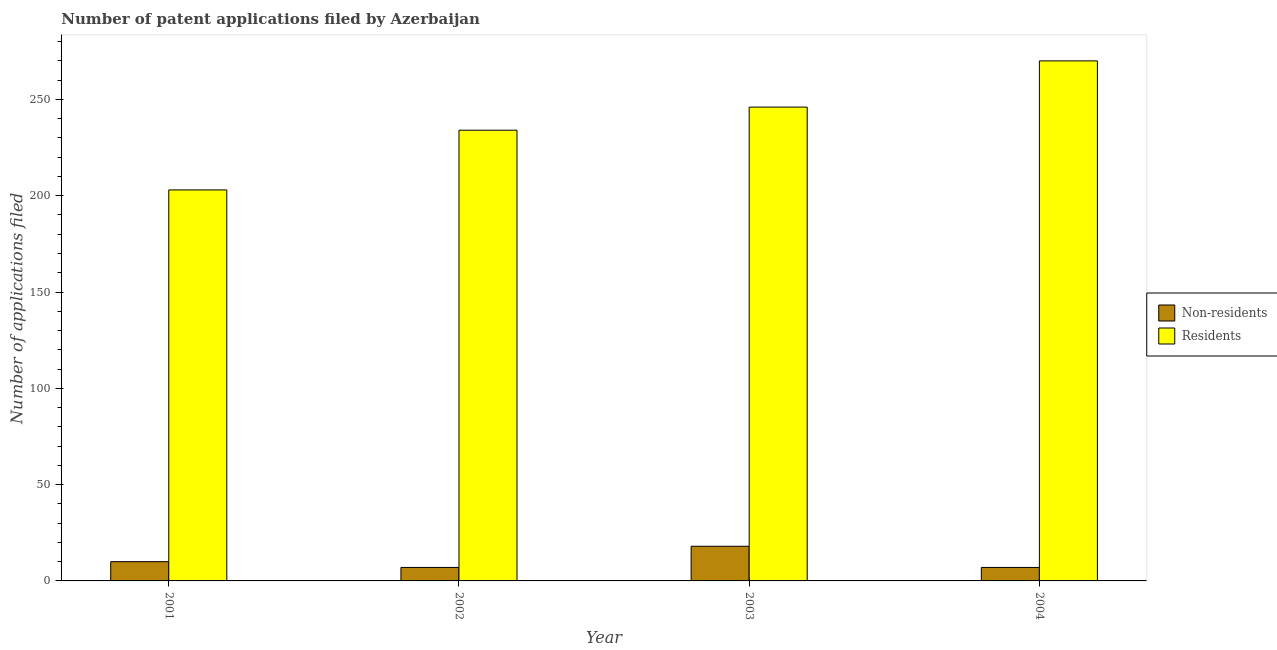Are the number of bars per tick equal to the number of legend labels?
Your answer should be compact. Yes. Are the number of bars on each tick of the X-axis equal?
Your response must be concise. Yes. How many bars are there on the 1st tick from the right?
Ensure brevity in your answer.  2. What is the number of patent applications by non residents in 2001?
Offer a very short reply. 10. Across all years, what is the maximum number of patent applications by non residents?
Your answer should be compact. 18. Across all years, what is the minimum number of patent applications by non residents?
Give a very brief answer. 7. In which year was the number of patent applications by non residents maximum?
Provide a short and direct response. 2003. In which year was the number of patent applications by residents minimum?
Give a very brief answer. 2001. What is the total number of patent applications by non residents in the graph?
Offer a very short reply. 42. What is the difference between the number of patent applications by non residents in 2001 and that in 2002?
Offer a terse response. 3. What is the difference between the number of patent applications by non residents in 2003 and the number of patent applications by residents in 2002?
Offer a very short reply. 11. In the year 2002, what is the difference between the number of patent applications by residents and number of patent applications by non residents?
Make the answer very short. 0. What is the ratio of the number of patent applications by residents in 2002 to that in 2003?
Your response must be concise. 0.95. Is the difference between the number of patent applications by residents in 2001 and 2003 greater than the difference between the number of patent applications by non residents in 2001 and 2003?
Give a very brief answer. No. What is the difference between the highest and the second highest number of patent applications by non residents?
Your answer should be very brief. 8. What is the difference between the highest and the lowest number of patent applications by non residents?
Give a very brief answer. 11. Is the sum of the number of patent applications by residents in 2002 and 2003 greater than the maximum number of patent applications by non residents across all years?
Keep it short and to the point. Yes. What does the 2nd bar from the left in 2003 represents?
Your answer should be compact. Residents. What does the 2nd bar from the right in 2003 represents?
Make the answer very short. Non-residents. How many bars are there?
Your answer should be compact. 8. Are all the bars in the graph horizontal?
Your answer should be compact. No. What is the difference between two consecutive major ticks on the Y-axis?
Make the answer very short. 50. Are the values on the major ticks of Y-axis written in scientific E-notation?
Keep it short and to the point. No. Does the graph contain any zero values?
Keep it short and to the point. No. Where does the legend appear in the graph?
Provide a succinct answer. Center right. How are the legend labels stacked?
Your answer should be very brief. Vertical. What is the title of the graph?
Your answer should be very brief. Number of patent applications filed by Azerbaijan. What is the label or title of the Y-axis?
Your answer should be compact. Number of applications filed. What is the Number of applications filed in Residents in 2001?
Your response must be concise. 203. What is the Number of applications filed of Residents in 2002?
Make the answer very short. 234. What is the Number of applications filed of Residents in 2003?
Make the answer very short. 246. What is the Number of applications filed of Non-residents in 2004?
Provide a short and direct response. 7. What is the Number of applications filed in Residents in 2004?
Give a very brief answer. 270. Across all years, what is the maximum Number of applications filed of Non-residents?
Your response must be concise. 18. Across all years, what is the maximum Number of applications filed of Residents?
Offer a very short reply. 270. Across all years, what is the minimum Number of applications filed in Residents?
Give a very brief answer. 203. What is the total Number of applications filed in Residents in the graph?
Your answer should be very brief. 953. What is the difference between the Number of applications filed in Residents in 2001 and that in 2002?
Keep it short and to the point. -31. What is the difference between the Number of applications filed of Non-residents in 2001 and that in 2003?
Offer a terse response. -8. What is the difference between the Number of applications filed of Residents in 2001 and that in 2003?
Your answer should be very brief. -43. What is the difference between the Number of applications filed of Non-residents in 2001 and that in 2004?
Keep it short and to the point. 3. What is the difference between the Number of applications filed of Residents in 2001 and that in 2004?
Make the answer very short. -67. What is the difference between the Number of applications filed of Residents in 2002 and that in 2003?
Your answer should be very brief. -12. What is the difference between the Number of applications filed of Residents in 2002 and that in 2004?
Give a very brief answer. -36. What is the difference between the Number of applications filed of Non-residents in 2001 and the Number of applications filed of Residents in 2002?
Your answer should be very brief. -224. What is the difference between the Number of applications filed in Non-residents in 2001 and the Number of applications filed in Residents in 2003?
Ensure brevity in your answer.  -236. What is the difference between the Number of applications filed in Non-residents in 2001 and the Number of applications filed in Residents in 2004?
Offer a terse response. -260. What is the difference between the Number of applications filed of Non-residents in 2002 and the Number of applications filed of Residents in 2003?
Ensure brevity in your answer.  -239. What is the difference between the Number of applications filed of Non-residents in 2002 and the Number of applications filed of Residents in 2004?
Keep it short and to the point. -263. What is the difference between the Number of applications filed of Non-residents in 2003 and the Number of applications filed of Residents in 2004?
Give a very brief answer. -252. What is the average Number of applications filed in Residents per year?
Provide a short and direct response. 238.25. In the year 2001, what is the difference between the Number of applications filed of Non-residents and Number of applications filed of Residents?
Your answer should be compact. -193. In the year 2002, what is the difference between the Number of applications filed of Non-residents and Number of applications filed of Residents?
Offer a very short reply. -227. In the year 2003, what is the difference between the Number of applications filed of Non-residents and Number of applications filed of Residents?
Make the answer very short. -228. In the year 2004, what is the difference between the Number of applications filed in Non-residents and Number of applications filed in Residents?
Your response must be concise. -263. What is the ratio of the Number of applications filed in Non-residents in 2001 to that in 2002?
Give a very brief answer. 1.43. What is the ratio of the Number of applications filed in Residents in 2001 to that in 2002?
Offer a terse response. 0.87. What is the ratio of the Number of applications filed in Non-residents in 2001 to that in 2003?
Your answer should be very brief. 0.56. What is the ratio of the Number of applications filed of Residents in 2001 to that in 2003?
Offer a terse response. 0.83. What is the ratio of the Number of applications filed in Non-residents in 2001 to that in 2004?
Your answer should be very brief. 1.43. What is the ratio of the Number of applications filed of Residents in 2001 to that in 2004?
Make the answer very short. 0.75. What is the ratio of the Number of applications filed in Non-residents in 2002 to that in 2003?
Offer a terse response. 0.39. What is the ratio of the Number of applications filed of Residents in 2002 to that in 2003?
Your response must be concise. 0.95. What is the ratio of the Number of applications filed in Non-residents in 2002 to that in 2004?
Offer a very short reply. 1. What is the ratio of the Number of applications filed in Residents in 2002 to that in 2004?
Your answer should be compact. 0.87. What is the ratio of the Number of applications filed of Non-residents in 2003 to that in 2004?
Provide a short and direct response. 2.57. What is the ratio of the Number of applications filed of Residents in 2003 to that in 2004?
Keep it short and to the point. 0.91. What is the difference between the highest and the lowest Number of applications filed of Residents?
Make the answer very short. 67. 